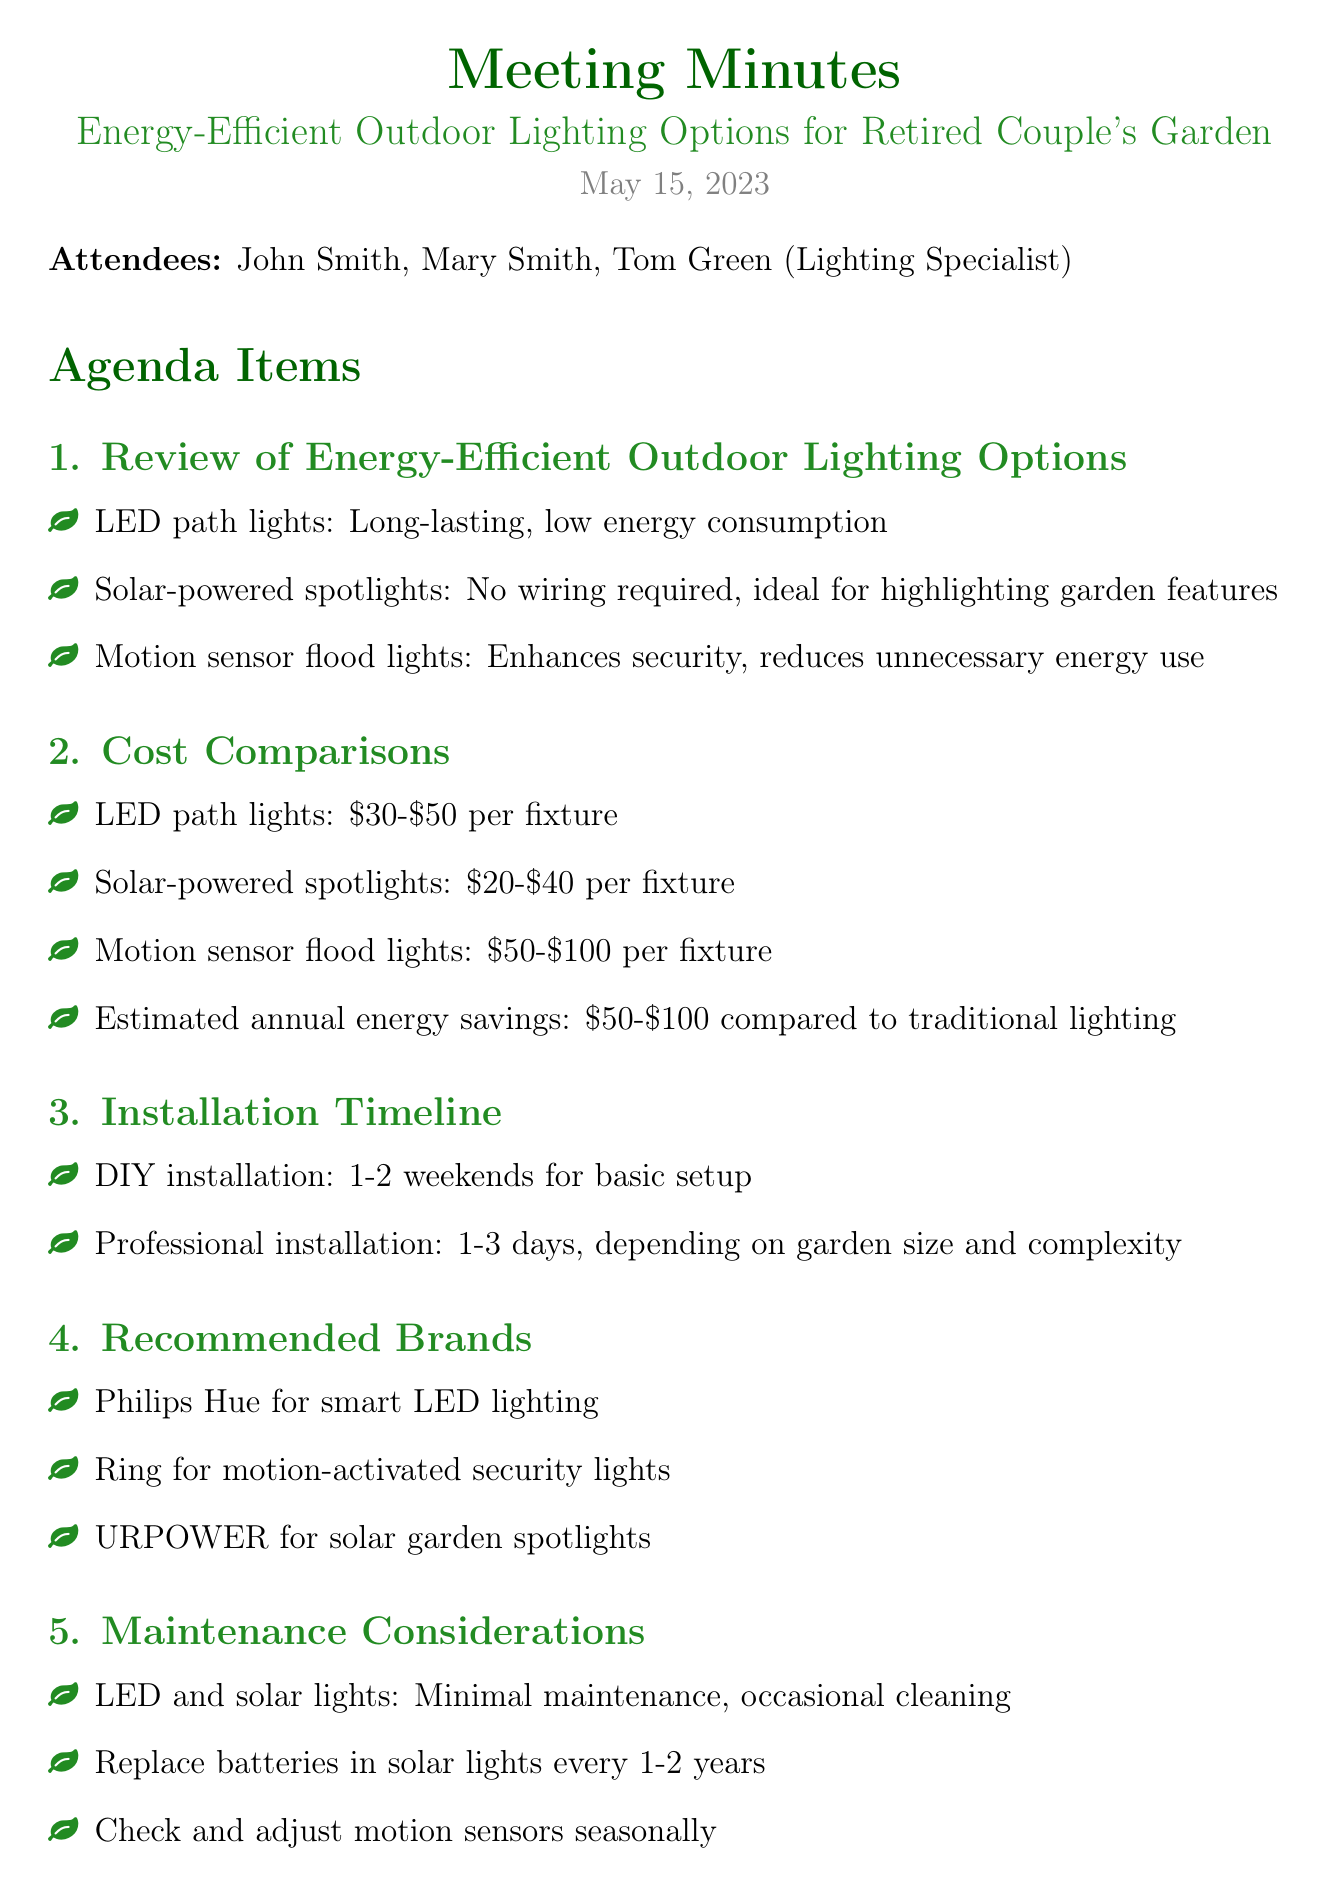what is the meeting date? The meeting date is clearly stated in the document as May 15, 2023.
Answer: May 15, 2023 who is the lighting specialist attending the meeting? The lighting specialist attending the meeting is mentioned in the list of attendees.
Answer: Tom Green what is the estimated annual energy savings compared to traditional lighting? The estimated annual energy savings is found in the cost comparisons section of the document.
Answer: 50-100 dollars how long is the DIY installation timeline? The DIY installation timeline is specified in the installation timeline section.
Answer: 1-2 weekends which brand is recommended for solar garden spotlights? The recommended brands section lists various brands, including one for solar garden spotlights.
Answer: URPOWER what is one maintenance consideration for solar lights? The maintenance considerations section specifies that solar lights require battery replacement every 1-2 years.
Answer: Replace batteries every 1-2 years what is the cost range for motion sensor flood lights? The cost comparisons section provides the price range for motion sensor flood lights.
Answer: 50-100 dollars how long does professional installation take? The document states the duration for professional installation in the installation timeline section.
Answer: 1-3 days 